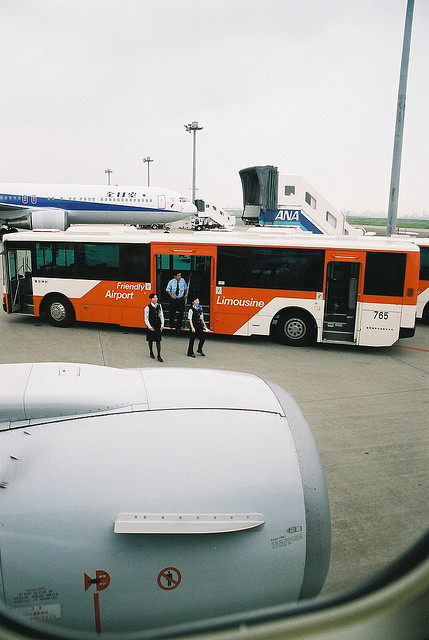Please transcribe the text information in this image. Friondly Airport Limousine ANA 7865 